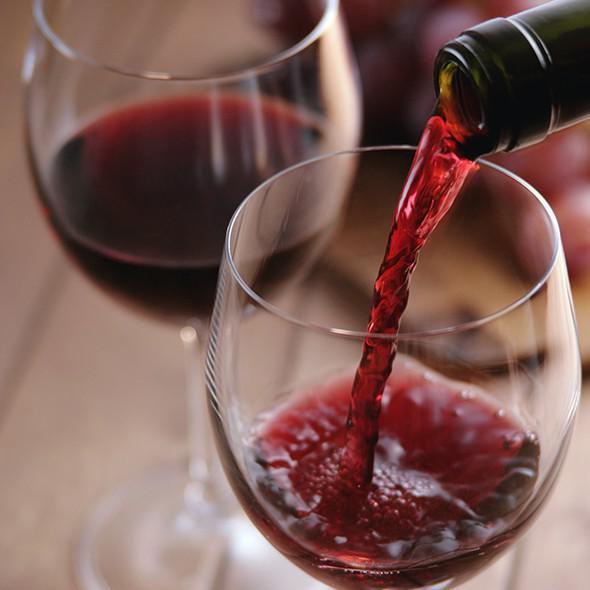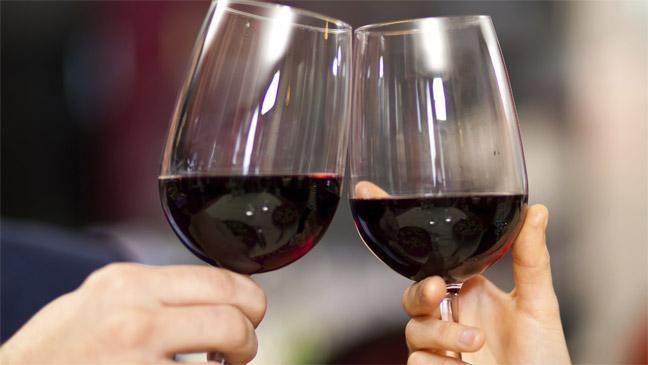The first image is the image on the left, the second image is the image on the right. Assess this claim about the two images: "There are two glasses in each of the images.". Correct or not? Answer yes or no. Yes. The first image is the image on the left, the second image is the image on the right. Evaluate the accuracy of this statement regarding the images: "The left image contains two glasses of wine.". Is it true? Answer yes or no. Yes. 